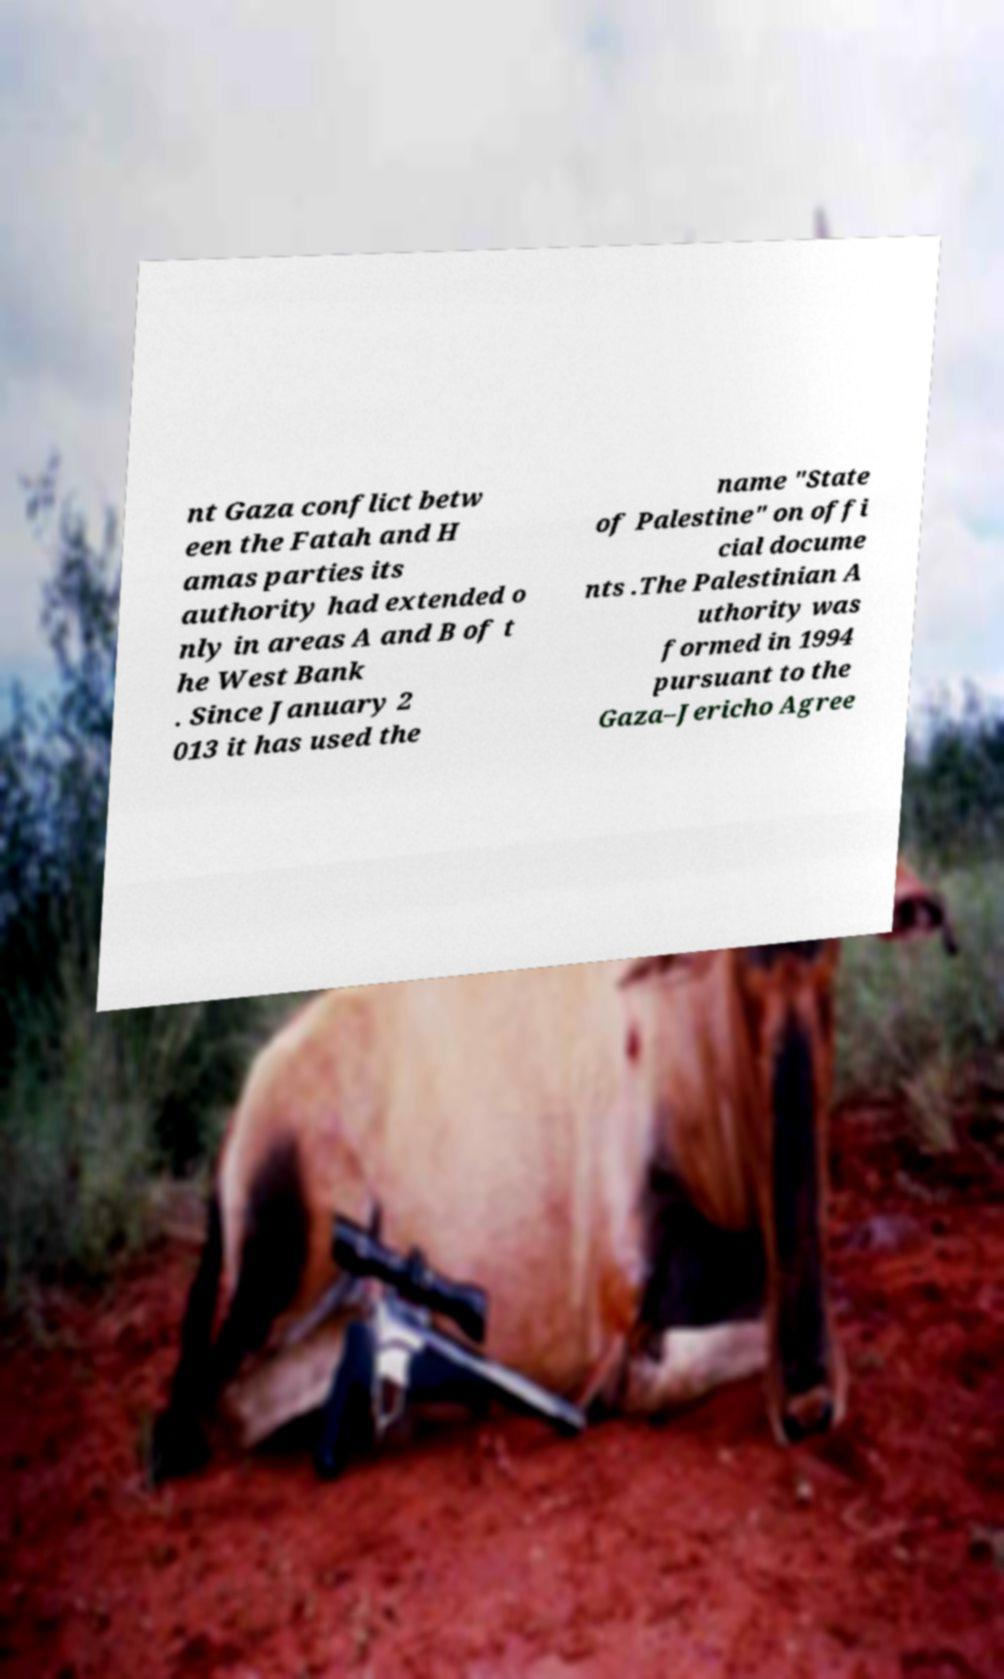Could you extract and type out the text from this image? nt Gaza conflict betw een the Fatah and H amas parties its authority had extended o nly in areas A and B of t he West Bank . Since January 2 013 it has used the name "State of Palestine" on offi cial docume nts .The Palestinian A uthority was formed in 1994 pursuant to the Gaza–Jericho Agree 